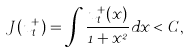Convert formula to latex. <formula><loc_0><loc_0><loc_500><loc_500>J ( u _ { t } ^ { + } ) = \int \frac { u ^ { + } _ { t } ( x ) } { 1 + x ^ { 2 } } d x < C ,</formula> 